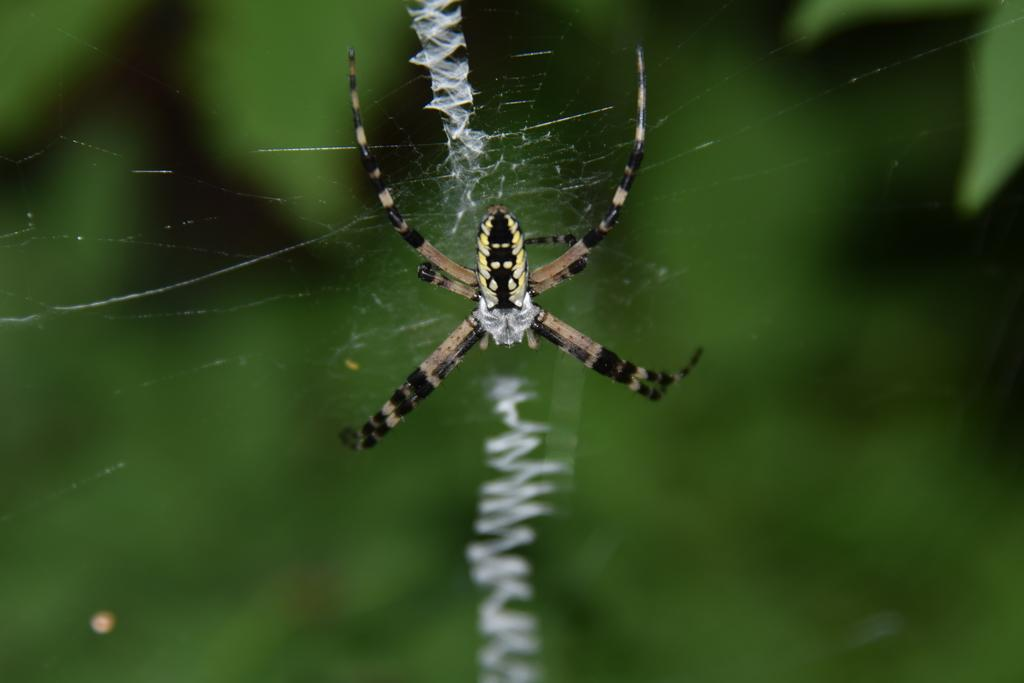What is the main subject of the image? There is a spider in the image. Where is the spider located? The spider is in a spider web. Can you describe the background of the image? The background of the image is blurry and black. What type of plastic material can be seen in the image? There is no plastic material present in the image. Is there a stream visible in the image? There is no stream present in the image. 